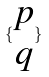Convert formula to latex. <formula><loc_0><loc_0><loc_500><loc_500>\{ \begin{matrix} p \\ q \end{matrix} \}</formula> 